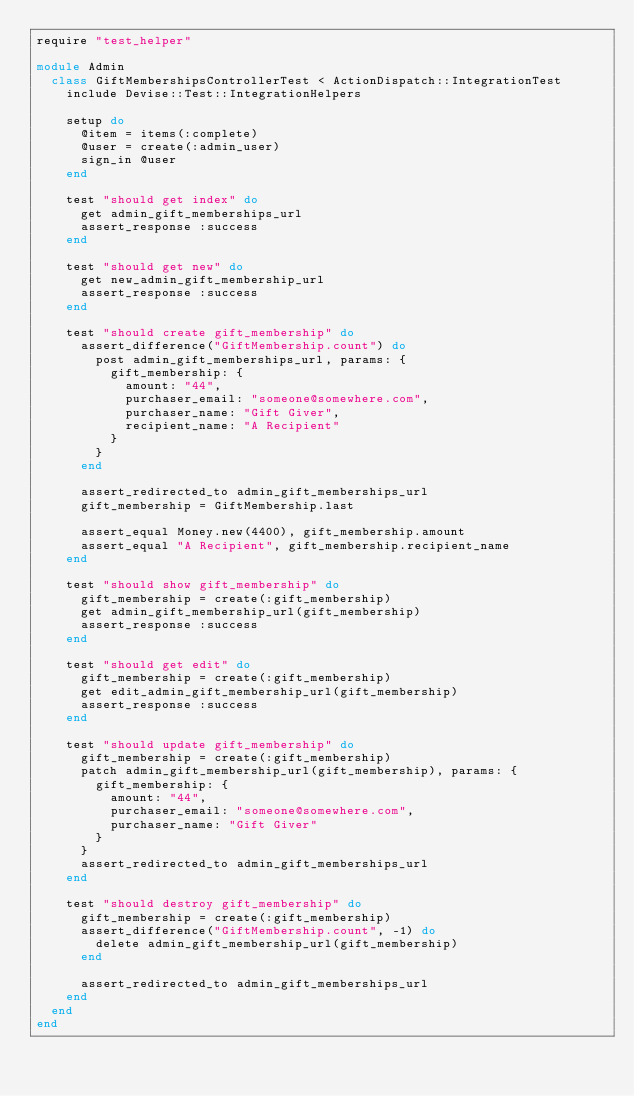Convert code to text. <code><loc_0><loc_0><loc_500><loc_500><_Ruby_>require "test_helper"

module Admin
  class GiftMembershipsControllerTest < ActionDispatch::IntegrationTest
    include Devise::Test::IntegrationHelpers

    setup do
      @item = items(:complete)
      @user = create(:admin_user)
      sign_in @user
    end

    test "should get index" do
      get admin_gift_memberships_url
      assert_response :success
    end

    test "should get new" do
      get new_admin_gift_membership_url
      assert_response :success
    end

    test "should create gift_membership" do
      assert_difference("GiftMembership.count") do
        post admin_gift_memberships_url, params: {
          gift_membership: {
            amount: "44",
            purchaser_email: "someone@somewhere.com",
            purchaser_name: "Gift Giver",
            recipient_name: "A Recipient"
          }
        }
      end

      assert_redirected_to admin_gift_memberships_url
      gift_membership = GiftMembership.last

      assert_equal Money.new(4400), gift_membership.amount
      assert_equal "A Recipient", gift_membership.recipient_name
    end

    test "should show gift_membership" do
      gift_membership = create(:gift_membership)
      get admin_gift_membership_url(gift_membership)
      assert_response :success
    end

    test "should get edit" do
      gift_membership = create(:gift_membership)
      get edit_admin_gift_membership_url(gift_membership)
      assert_response :success
    end

    test "should update gift_membership" do
      gift_membership = create(:gift_membership)
      patch admin_gift_membership_url(gift_membership), params: {
        gift_membership: {
          amount: "44",
          purchaser_email: "someone@somewhere.com",
          purchaser_name: "Gift Giver"
        }
      }
      assert_redirected_to admin_gift_memberships_url
    end

    test "should destroy gift_membership" do
      gift_membership = create(:gift_membership)
      assert_difference("GiftMembership.count", -1) do
        delete admin_gift_membership_url(gift_membership)
      end

      assert_redirected_to admin_gift_memberships_url
    end
  end
end
</code> 